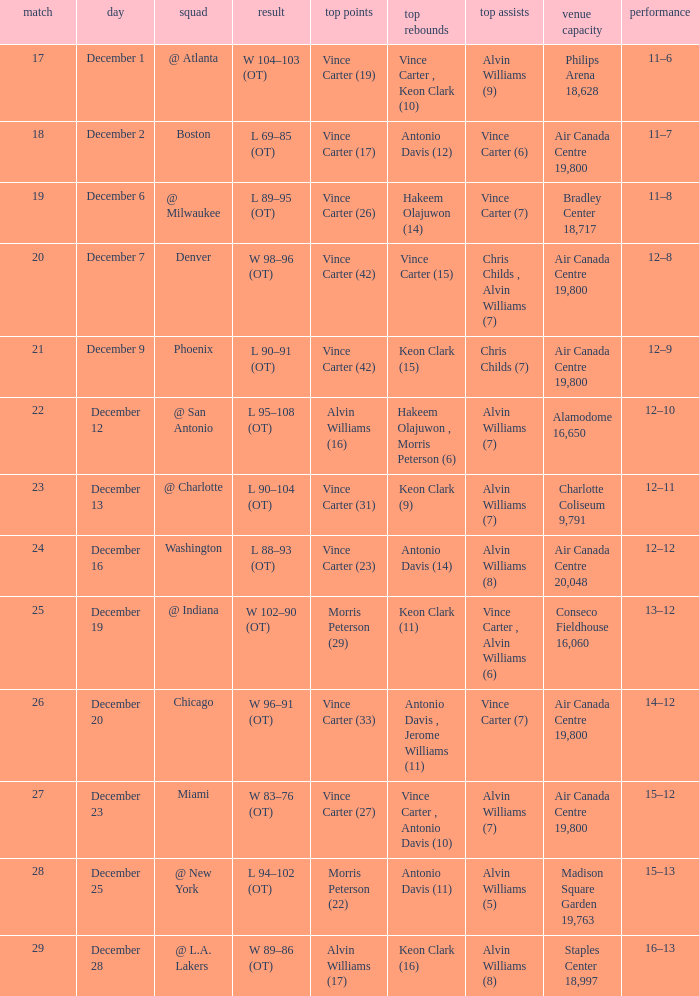Who scored the most points against Washington? Vince Carter (23). Could you help me parse every detail presented in this table? {'header': ['match', 'day', 'squad', 'result', 'top points', 'top rebounds', 'top assists', 'venue capacity', 'performance'], 'rows': [['17', 'December 1', '@ Atlanta', 'W 104–103 (OT)', 'Vince Carter (19)', 'Vince Carter , Keon Clark (10)', 'Alvin Williams (9)', 'Philips Arena 18,628', '11–6'], ['18', 'December 2', 'Boston', 'L 69–85 (OT)', 'Vince Carter (17)', 'Antonio Davis (12)', 'Vince Carter (6)', 'Air Canada Centre 19,800', '11–7'], ['19', 'December 6', '@ Milwaukee', 'L 89–95 (OT)', 'Vince Carter (26)', 'Hakeem Olajuwon (14)', 'Vince Carter (7)', 'Bradley Center 18,717', '11–8'], ['20', 'December 7', 'Denver', 'W 98–96 (OT)', 'Vince Carter (42)', 'Vince Carter (15)', 'Chris Childs , Alvin Williams (7)', 'Air Canada Centre 19,800', '12–8'], ['21', 'December 9', 'Phoenix', 'L 90–91 (OT)', 'Vince Carter (42)', 'Keon Clark (15)', 'Chris Childs (7)', 'Air Canada Centre 19,800', '12–9'], ['22', 'December 12', '@ San Antonio', 'L 95–108 (OT)', 'Alvin Williams (16)', 'Hakeem Olajuwon , Morris Peterson (6)', 'Alvin Williams (7)', 'Alamodome 16,650', '12–10'], ['23', 'December 13', '@ Charlotte', 'L 90–104 (OT)', 'Vince Carter (31)', 'Keon Clark (9)', 'Alvin Williams (7)', 'Charlotte Coliseum 9,791', '12–11'], ['24', 'December 16', 'Washington', 'L 88–93 (OT)', 'Vince Carter (23)', 'Antonio Davis (14)', 'Alvin Williams (8)', 'Air Canada Centre 20,048', '12–12'], ['25', 'December 19', '@ Indiana', 'W 102–90 (OT)', 'Morris Peterson (29)', 'Keon Clark (11)', 'Vince Carter , Alvin Williams (6)', 'Conseco Fieldhouse 16,060', '13–12'], ['26', 'December 20', 'Chicago', 'W 96–91 (OT)', 'Vince Carter (33)', 'Antonio Davis , Jerome Williams (11)', 'Vince Carter (7)', 'Air Canada Centre 19,800', '14–12'], ['27', 'December 23', 'Miami', 'W 83–76 (OT)', 'Vince Carter (27)', 'Vince Carter , Antonio Davis (10)', 'Alvin Williams (7)', 'Air Canada Centre 19,800', '15–12'], ['28', 'December 25', '@ New York', 'L 94–102 (OT)', 'Morris Peterson (22)', 'Antonio Davis (11)', 'Alvin Williams (5)', 'Madison Square Garden 19,763', '15–13'], ['29', 'December 28', '@ L.A. Lakers', 'W 89–86 (OT)', 'Alvin Williams (17)', 'Keon Clark (16)', 'Alvin Williams (8)', 'Staples Center 18,997', '16–13']]} 